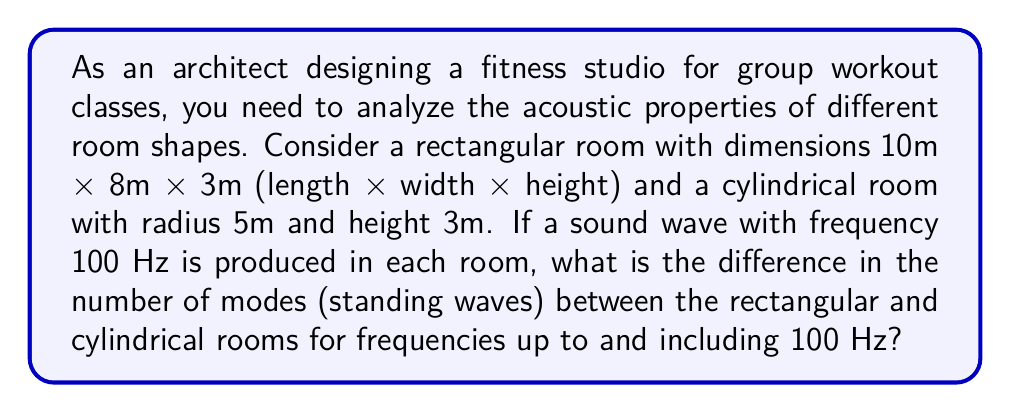Teach me how to tackle this problem. To solve this problem, we need to calculate the number of modes for both room shapes and then find the difference. Let's approach this step-by-step:

1. For a rectangular room, the number of modes up to a frequency $f$ is given by:

   $$N(f) = \frac{4\pi V f^3}{3c^3} + \frac{\pi S f^2}{4c^2} + \frac{L f}{8c}$$

   Where $V$ is the volume, $S$ is the surface area, $L$ is the sum of the edge lengths, and $c$ is the speed of sound (approx. 343 m/s).

2. For the rectangular room:
   $V = 10 \times 8 \times 3 = 240$ m³
   $S = 2(10 \times 8 + 10 \times 3 + 8 \times 3) = 308$ m²
   $L = 4(10 + 8 + 3) = 84$ m

3. Substituting into the equation:

   $$N_{rect}(100) = \frac{4\pi \times 240 \times 100^3}{3 \times 343^3} + \frac{\pi \times 308 \times 100^2}{4 \times 343^2} + \frac{84 \times 100}{8 \times 343} \approx 25.92$$

4. For a cylindrical room, the number of modes is approximated by:

   $$N(f) = \frac{4\pi V f^3}{3c^3} + \frac{\pi S f^2}{4c^2} + \frac{L f}{8c} + \frac{1}{2}$$

5. For the cylindrical room:
   $V = \pi r^2 h = \pi \times 5^2 \times 3 \approx 235.62$ m³
   $S = 2\pi r^2 + 2\pi r h = 2\pi \times 5^2 + 2\pi \times 5 \times 3 \approx 251.33$ m²
   $L = 2(2\pi r + h) = 2(2\pi \times 5 + 3) \approx 69.83$ m

6. Substituting into the equation:

   $$N_{cyl}(100) = \frac{4\pi \times 235.62 \times 100^3}{3 \times 343^3} + \frac{\pi \times 251.33 \times 100^2}{4 \times 343^2} + \frac{69.83 \times 100}{8 \times 343} + \frac{1}{2} \approx 22.95$$

7. The difference in the number of modes:
   $\Delta N = N_{rect}(100) - N_{cyl}(100) \approx 25.92 - 22.95 = 2.97$

8. Since we're dealing with discrete modes, we round to the nearest integer:
   $\Delta N \approx 3$
Answer: 3 modes 